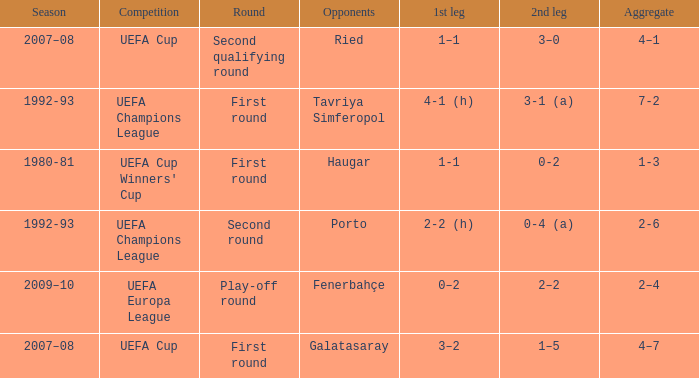 what's the competition where aggregate is 4–7 UEFA Cup. 